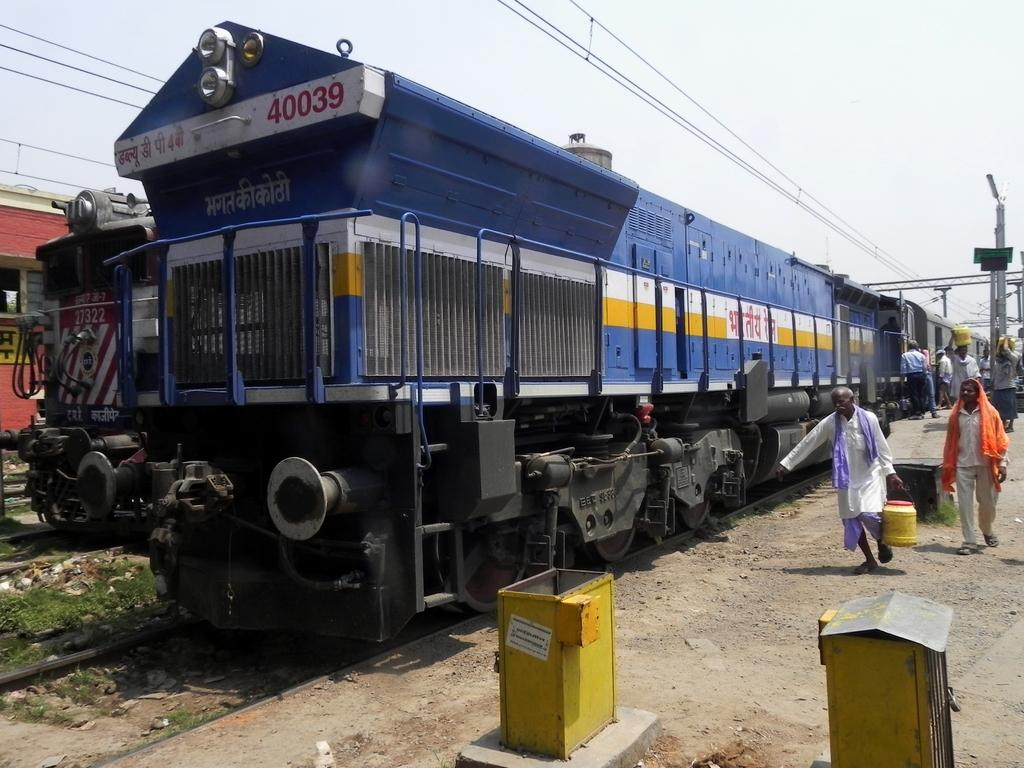What are the people in the image doing? The people in the image are walking. What are some people holding in the image? Some people are holding something, but the facts do not specify what they are holding. What can be seen in the image besides people walking? There are poles, wires, yellow color boxes, and trains on railway tracks in the image. What is the color of the sky in the image? The sky is in white and blue color. What type of beetle can be seen crawling on the yellow color boxes in the image? There is no beetle present in the image; the facts only mention yellow color boxes and do not mention any insects or animals. What type of apparel is the person wearing in the image? The facts do not specify the type of apparel worn by the people in the image. 